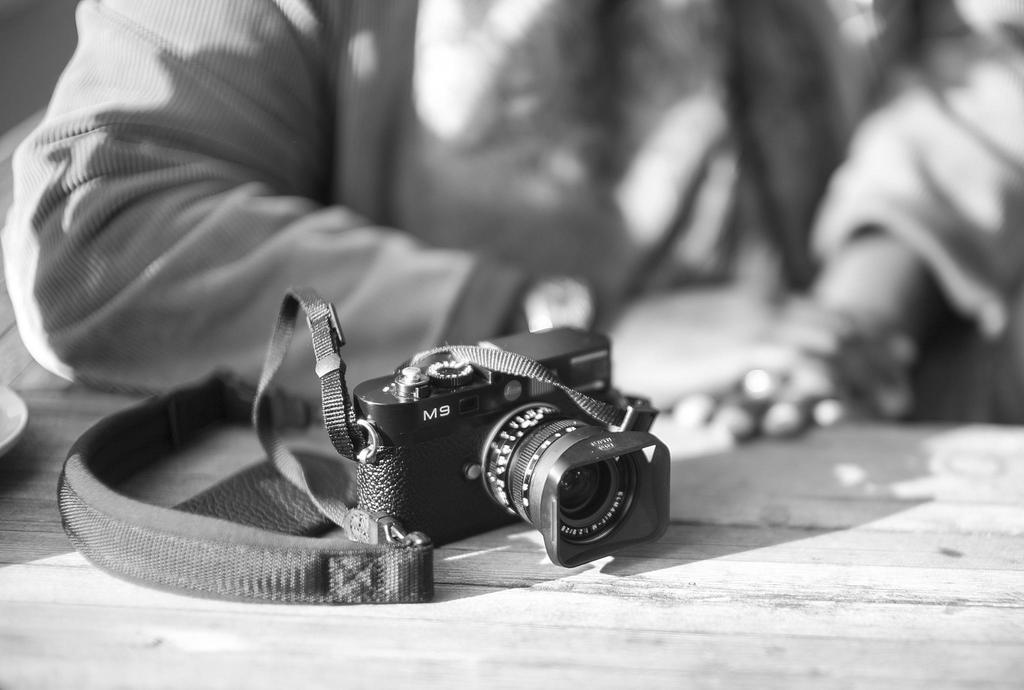<image>
Provide a brief description of the given image. An MS camera sits on a wooden table. 